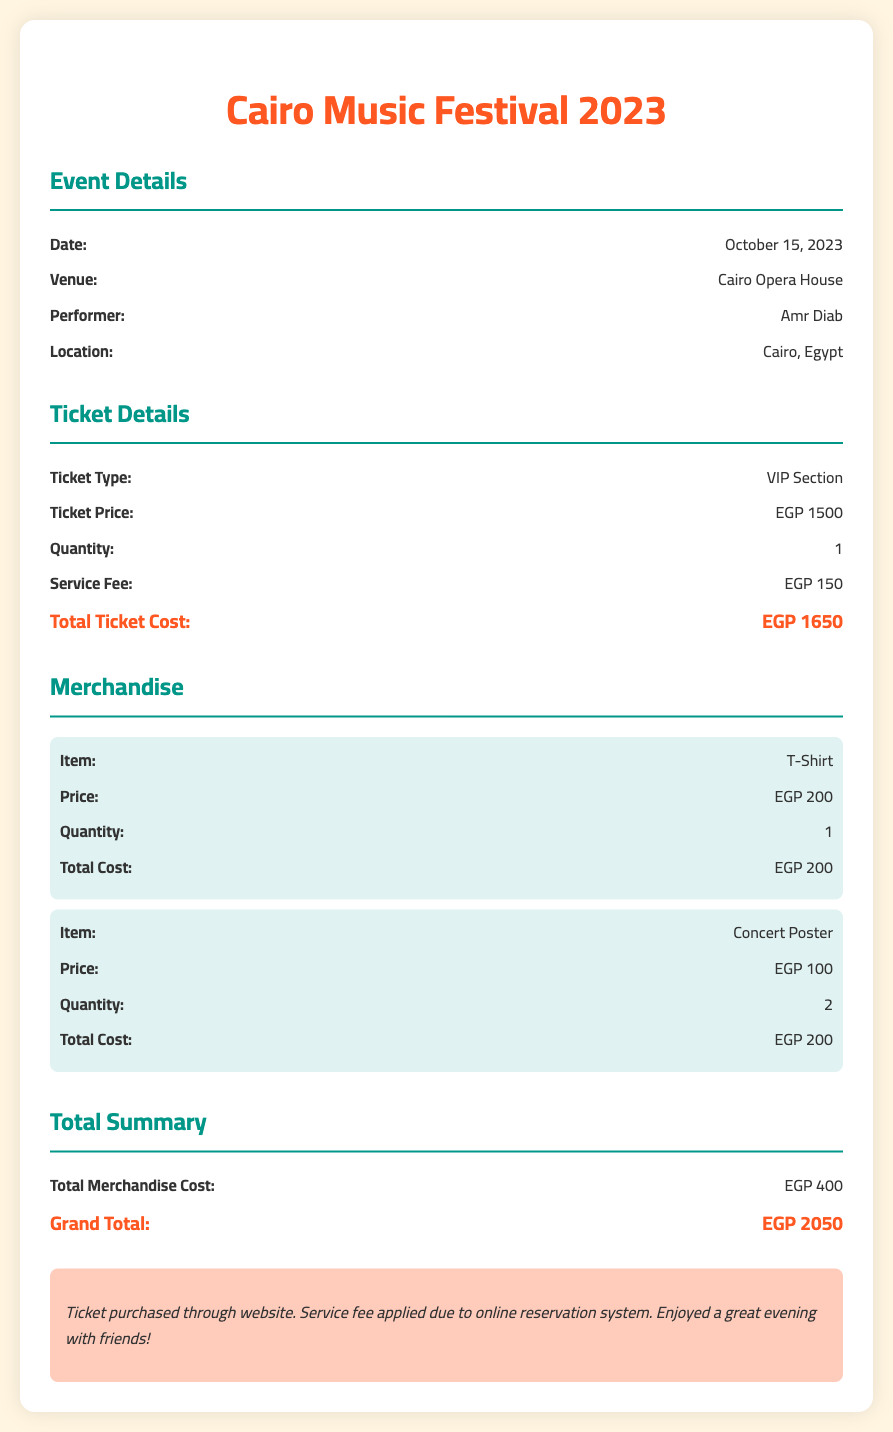What is the date of the event? The date is provided in the event details section of the document.
Answer: October 15, 2023 Where is the concert held? The venue information indicates where the event takes place.
Answer: Cairo Opera House What is the ticket price? The ticket price is specified under the ticket details section.
Answer: EGP 1500 How much is the service fee? The service fee is clearly mentioned along with the ticket price.
Answer: EGP 150 What merchandise did you purchase? Merchandise items are listed in their respective section of the document.
Answer: T-Shirt, Concert Poster What is the total merchandise cost? The total merchandise cost is summarized at the end of the merchandise section.
Answer: EGP 400 What is the grand total cost? The grand total is provided in the total summary section of the document.
Answer: EGP 2050 How many concert posters were purchased? The quantity for the concert poster is listed in the merchandise section.
Answer: 2 Who was the performer at the concert? The performer is mentioned in the event details section of the document.
Answer: Amr Diab 